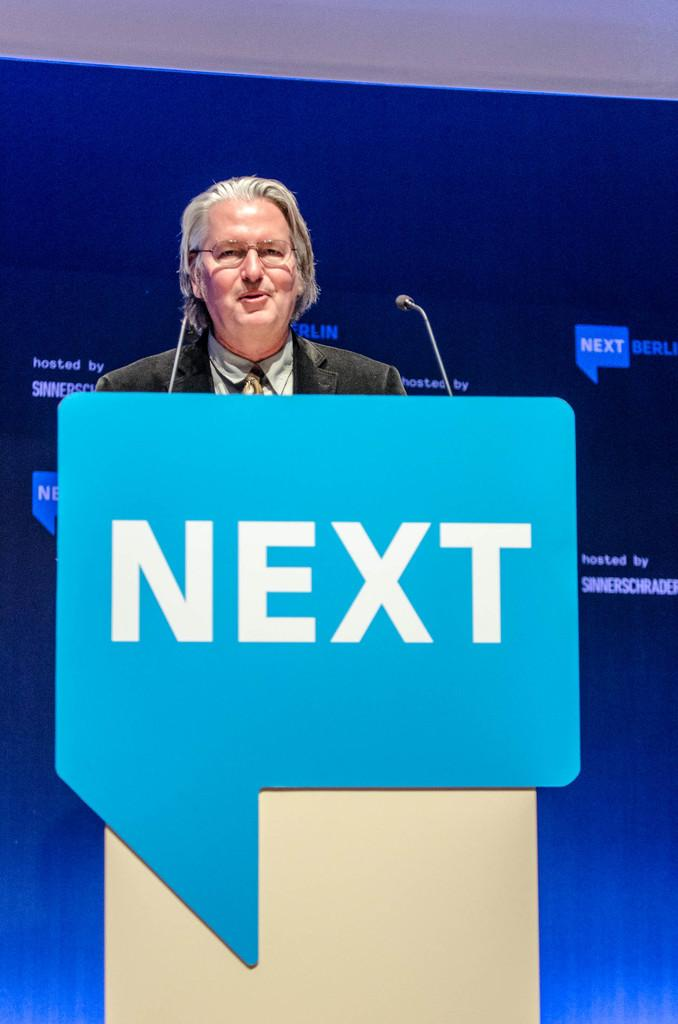What is the person in the image doing? The person is standing in front of a table. What can be seen on the table in the image? There is a board with text in the image. What objects are present that might be used for amplifying sound? There are microphones in the image. What additional text can be seen in the background of the image? There is a banner with text in the background of the image. What type of fuel is being used by the ducks in the image? There are no ducks present in the image, so it is not possible to determine what type of fuel they might be using. 